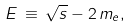Convert formula to latex. <formula><loc_0><loc_0><loc_500><loc_500>E \, \equiv \, \sqrt { s } - 2 \, m _ { e } ,</formula> 